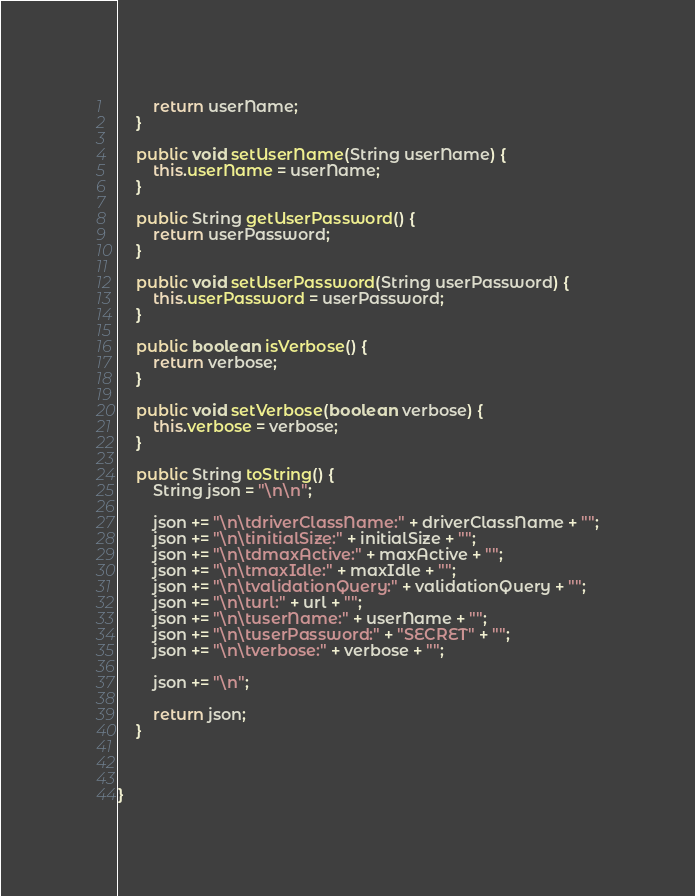Convert code to text. <code><loc_0><loc_0><loc_500><loc_500><_Java_>		return userName;
	}

	public void setUserName(String userName) {
		this.userName = userName;
	}

	public String getUserPassword() {
		return userPassword;
	}

	public void setUserPassword(String userPassword) {
		this.userPassword = userPassword;
	}

	public boolean isVerbose() {
		return verbose;
	}

	public void setVerbose(boolean verbose) {
		this.verbose = verbose;
	}

	public String toString() {
		String json = "\n\n";

		json += "\n\tdriverClassName:" + driverClassName + "";
		json += "\n\tinitialSize:" + initialSize + "";
		json += "\n\tdmaxActive:" + maxActive + "";
		json += "\n\tmaxIdle:" + maxIdle + "";
		json += "\n\tvalidationQuery:" + validationQuery + "";
		json += "\n\turl:" + url + "";
		json += "\n\tuserName:" + userName + "";
		json += "\n\tuserPassword:" + "SECRET" + "";
		json += "\n\tverbose:" + verbose + "";

		json += "\n";

		return json;
	}
	
	

}
</code> 